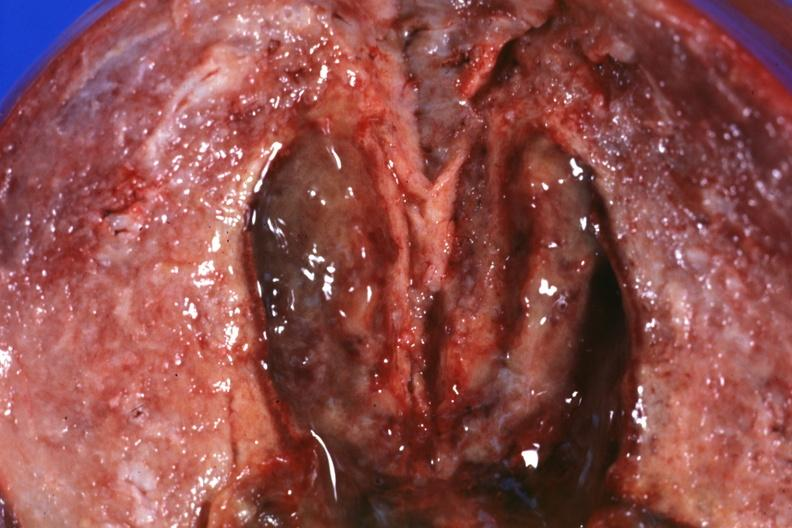s palmar crease normal present?
Answer the question using a single word or phrase. No 